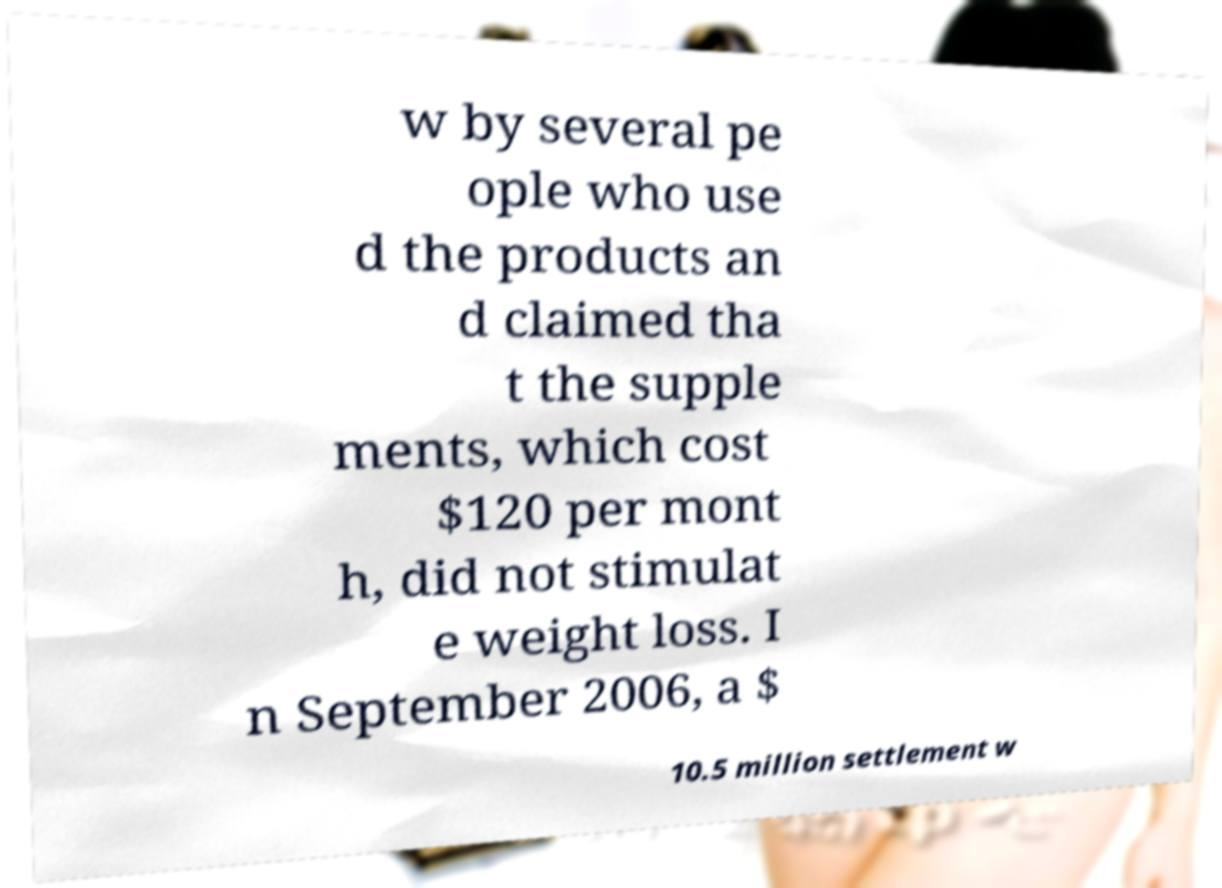For documentation purposes, I need the text within this image transcribed. Could you provide that? w by several pe ople who use d the products an d claimed tha t the supple ments, which cost $120 per mont h, did not stimulat e weight loss. I n September 2006, a $ 10.5 million settlement w 